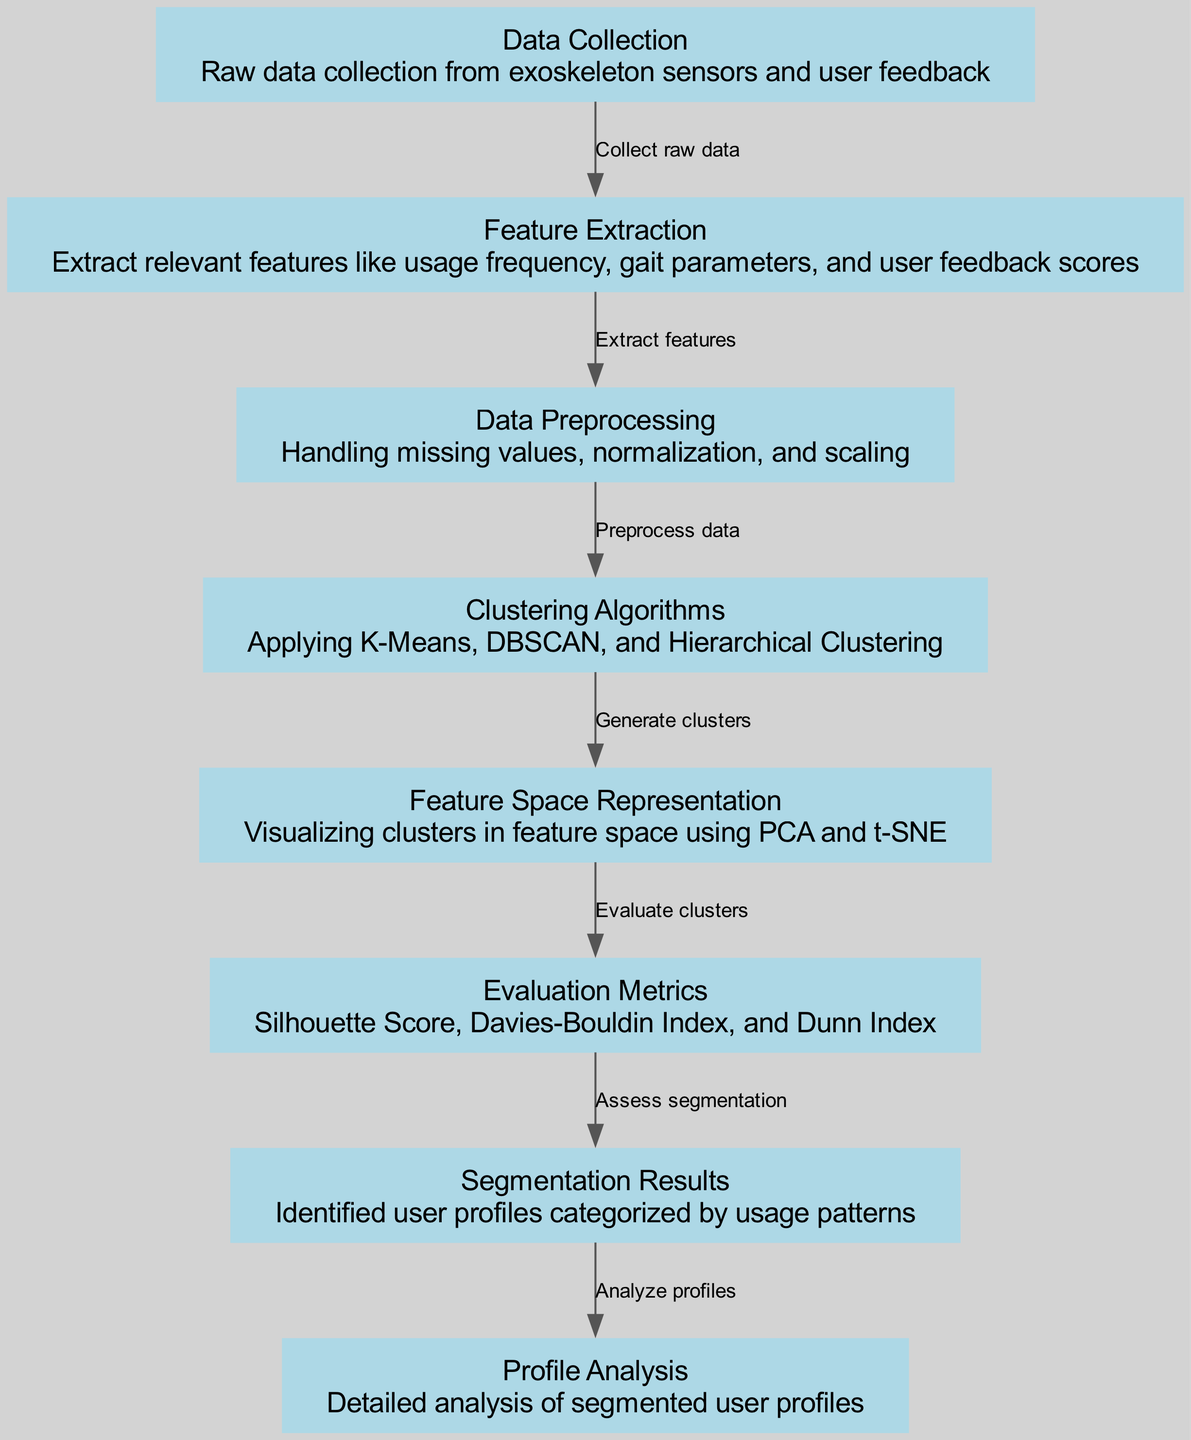What is the first step in the diagram? The first node in the diagram is "Data Collection," which represents the initial action of gathering raw data from exoskeleton sensors and user feedback.
Answer: Data Collection How many nodes are present in the diagram? By counting the nodes listed in the data, there are a total of 8 nodes representing different stages or components in the clustering process.
Answer: 8 Which clustering algorithms are mentioned? The "Clustering Algorithms" node specifically lists K-Means, DBSCAN, and Hierarchical Clustering as the methods being applied for clustering usage patterns.
Answer: K-Means, DBSCAN, Hierarchical Clustering What is the relationship between feature extraction and data preprocessing? The edge connecting "Feature Extraction" to "Data Preprocessing" indicates that the purpose of feature extraction is to prepare relevant features that will then be processed to handle any issues such as missing values and normalization.
Answer: Extract features What do the evaluation metrics assess? The evaluation metrics serve to assess the quality and effectiveness of the generated clusters by utilizing different indices such as Silhouette Score, Davies-Bouldin Index, and Dunn Index.
Answer: Assess segmentation Which node comes directly after the "Clustering Algorithms"? The node that follows "Clustering Algorithms" is "Feature Space Representation," indicating the stage where visual representations of the clusters are created to understand their distribution within the feature space.
Answer: Feature Space Representation What type of data is processed in the "Data Preprocessing" step? The "Data Preprocessing" node describes that this step involves handling missing values, as well as normalizing and scaling the data to prepare it for clustering algorithms.
Answer: Missing values, normalization, and scaling Which step involves detailed analysis of user profiles? The final node, "Profile Analysis," indicates that it is the step where a detailed examination of the segmented user profiles is performed based on the results obtained during segmentation.
Answer: Profile Analysis 